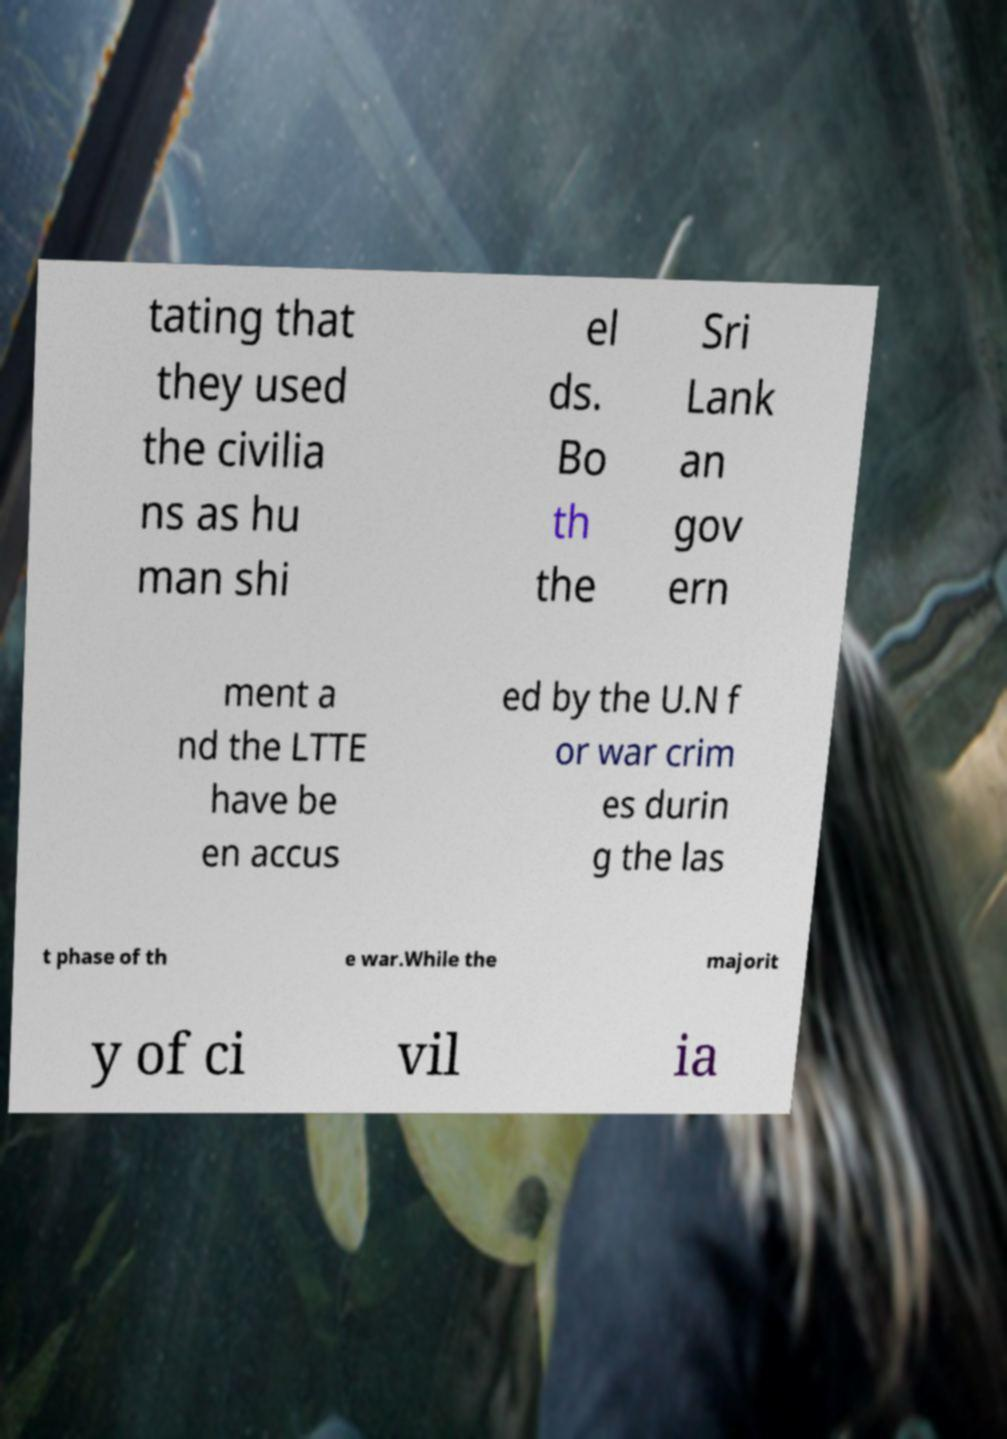There's text embedded in this image that I need extracted. Can you transcribe it verbatim? tating that they used the civilia ns as hu man shi el ds. Bo th the Sri Lank an gov ern ment a nd the LTTE have be en accus ed by the U.N f or war crim es durin g the las t phase of th e war.While the majorit y of ci vil ia 